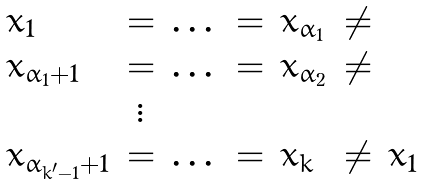<formula> <loc_0><loc_0><loc_500><loc_500>\begin{array} { l c l c l c l } x _ { 1 } & = & \dots & = & x _ { \alpha _ { 1 } } & \neq \\ x _ { \alpha _ { 1 } + 1 } & = & \dots & = & x _ { \alpha _ { 2 } } & \neq \\ & \vdots \\ x _ { \alpha _ { k ^ { \prime } - 1 } + 1 } & = & \dots & = & x _ { k } & \neq & x _ { 1 } \end{array}</formula> 